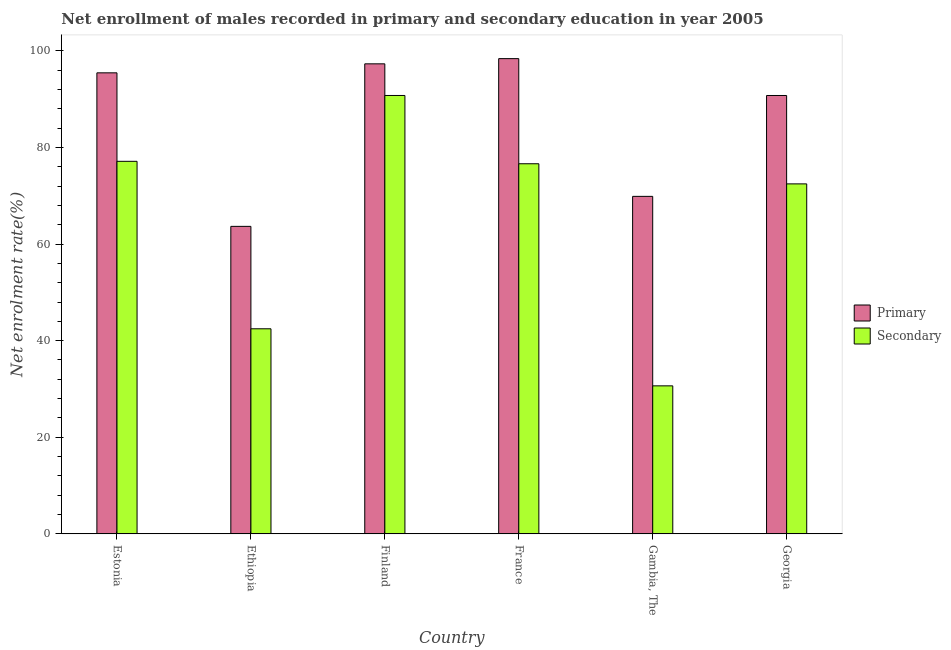How many bars are there on the 2nd tick from the right?
Offer a very short reply. 2. What is the enrollment rate in primary education in Estonia?
Your response must be concise. 95.44. Across all countries, what is the maximum enrollment rate in secondary education?
Provide a succinct answer. 90.76. Across all countries, what is the minimum enrollment rate in primary education?
Keep it short and to the point. 63.66. In which country was the enrollment rate in primary education minimum?
Offer a terse response. Ethiopia. What is the total enrollment rate in primary education in the graph?
Offer a very short reply. 515.42. What is the difference between the enrollment rate in secondary education in France and that in Gambia, The?
Provide a short and direct response. 45.98. What is the difference between the enrollment rate in secondary education in Georgia and the enrollment rate in primary education in Ethiopia?
Provide a succinct answer. 8.8. What is the average enrollment rate in secondary education per country?
Ensure brevity in your answer.  65.01. What is the difference between the enrollment rate in primary education and enrollment rate in secondary education in France?
Provide a short and direct response. 21.76. In how many countries, is the enrollment rate in secondary education greater than 16 %?
Your answer should be compact. 6. What is the ratio of the enrollment rate in primary education in Ethiopia to that in Finland?
Offer a terse response. 0.65. Is the enrollment rate in primary education in Ethiopia less than that in Finland?
Provide a succinct answer. Yes. What is the difference between the highest and the second highest enrollment rate in secondary education?
Offer a very short reply. 13.63. What is the difference between the highest and the lowest enrollment rate in primary education?
Ensure brevity in your answer.  34.73. Is the sum of the enrollment rate in primary education in Ethiopia and Georgia greater than the maximum enrollment rate in secondary education across all countries?
Provide a succinct answer. Yes. What does the 2nd bar from the left in Finland represents?
Provide a succinct answer. Secondary. What does the 2nd bar from the right in Ethiopia represents?
Provide a short and direct response. Primary. What is the difference between two consecutive major ticks on the Y-axis?
Keep it short and to the point. 20. Does the graph contain any zero values?
Your answer should be very brief. No. Does the graph contain grids?
Provide a short and direct response. No. Where does the legend appear in the graph?
Give a very brief answer. Center right. How many legend labels are there?
Your answer should be compact. 2. How are the legend labels stacked?
Your response must be concise. Vertical. What is the title of the graph?
Your answer should be compact. Net enrollment of males recorded in primary and secondary education in year 2005. What is the label or title of the X-axis?
Provide a succinct answer. Country. What is the label or title of the Y-axis?
Give a very brief answer. Net enrolment rate(%). What is the Net enrolment rate(%) of Primary in Estonia?
Provide a short and direct response. 95.44. What is the Net enrolment rate(%) of Secondary in Estonia?
Keep it short and to the point. 77.13. What is the Net enrolment rate(%) in Primary in Ethiopia?
Give a very brief answer. 63.66. What is the Net enrolment rate(%) in Secondary in Ethiopia?
Provide a short and direct response. 42.46. What is the Net enrolment rate(%) of Primary in Finland?
Keep it short and to the point. 97.31. What is the Net enrolment rate(%) in Secondary in Finland?
Your answer should be compact. 90.76. What is the Net enrolment rate(%) in Primary in France?
Your answer should be compact. 98.39. What is the Net enrolment rate(%) of Secondary in France?
Provide a short and direct response. 76.62. What is the Net enrolment rate(%) of Primary in Gambia, The?
Keep it short and to the point. 69.87. What is the Net enrolment rate(%) of Secondary in Gambia, The?
Offer a very short reply. 30.64. What is the Net enrolment rate(%) of Primary in Georgia?
Ensure brevity in your answer.  90.75. What is the Net enrolment rate(%) of Secondary in Georgia?
Make the answer very short. 72.46. Across all countries, what is the maximum Net enrolment rate(%) in Primary?
Provide a short and direct response. 98.39. Across all countries, what is the maximum Net enrolment rate(%) in Secondary?
Provide a short and direct response. 90.76. Across all countries, what is the minimum Net enrolment rate(%) in Primary?
Ensure brevity in your answer.  63.66. Across all countries, what is the minimum Net enrolment rate(%) in Secondary?
Your answer should be very brief. 30.64. What is the total Net enrolment rate(%) in Primary in the graph?
Your answer should be compact. 515.42. What is the total Net enrolment rate(%) in Secondary in the graph?
Ensure brevity in your answer.  390.06. What is the difference between the Net enrolment rate(%) in Primary in Estonia and that in Ethiopia?
Your answer should be compact. 31.79. What is the difference between the Net enrolment rate(%) in Secondary in Estonia and that in Ethiopia?
Make the answer very short. 34.67. What is the difference between the Net enrolment rate(%) in Primary in Estonia and that in Finland?
Keep it short and to the point. -1.86. What is the difference between the Net enrolment rate(%) in Secondary in Estonia and that in Finland?
Offer a very short reply. -13.63. What is the difference between the Net enrolment rate(%) in Primary in Estonia and that in France?
Your response must be concise. -2.94. What is the difference between the Net enrolment rate(%) in Secondary in Estonia and that in France?
Your answer should be very brief. 0.5. What is the difference between the Net enrolment rate(%) of Primary in Estonia and that in Gambia, The?
Ensure brevity in your answer.  25.57. What is the difference between the Net enrolment rate(%) of Secondary in Estonia and that in Gambia, The?
Your response must be concise. 46.48. What is the difference between the Net enrolment rate(%) in Primary in Estonia and that in Georgia?
Keep it short and to the point. 4.69. What is the difference between the Net enrolment rate(%) of Secondary in Estonia and that in Georgia?
Your response must be concise. 4.67. What is the difference between the Net enrolment rate(%) in Primary in Ethiopia and that in Finland?
Your answer should be compact. -33.65. What is the difference between the Net enrolment rate(%) of Secondary in Ethiopia and that in Finland?
Offer a terse response. -48.3. What is the difference between the Net enrolment rate(%) in Primary in Ethiopia and that in France?
Your answer should be very brief. -34.73. What is the difference between the Net enrolment rate(%) of Secondary in Ethiopia and that in France?
Your answer should be compact. -34.16. What is the difference between the Net enrolment rate(%) in Primary in Ethiopia and that in Gambia, The?
Your response must be concise. -6.21. What is the difference between the Net enrolment rate(%) of Secondary in Ethiopia and that in Gambia, The?
Make the answer very short. 11.81. What is the difference between the Net enrolment rate(%) in Primary in Ethiopia and that in Georgia?
Keep it short and to the point. -27.1. What is the difference between the Net enrolment rate(%) in Secondary in Ethiopia and that in Georgia?
Offer a terse response. -30. What is the difference between the Net enrolment rate(%) in Primary in Finland and that in France?
Give a very brief answer. -1.08. What is the difference between the Net enrolment rate(%) in Secondary in Finland and that in France?
Offer a very short reply. 14.14. What is the difference between the Net enrolment rate(%) of Primary in Finland and that in Gambia, The?
Your response must be concise. 27.44. What is the difference between the Net enrolment rate(%) of Secondary in Finland and that in Gambia, The?
Your answer should be compact. 60.12. What is the difference between the Net enrolment rate(%) in Primary in Finland and that in Georgia?
Ensure brevity in your answer.  6.55. What is the difference between the Net enrolment rate(%) in Secondary in Finland and that in Georgia?
Your answer should be very brief. 18.3. What is the difference between the Net enrolment rate(%) of Primary in France and that in Gambia, The?
Provide a succinct answer. 28.51. What is the difference between the Net enrolment rate(%) of Secondary in France and that in Gambia, The?
Offer a terse response. 45.98. What is the difference between the Net enrolment rate(%) in Primary in France and that in Georgia?
Offer a very short reply. 7.63. What is the difference between the Net enrolment rate(%) in Secondary in France and that in Georgia?
Provide a short and direct response. 4.17. What is the difference between the Net enrolment rate(%) of Primary in Gambia, The and that in Georgia?
Make the answer very short. -20.88. What is the difference between the Net enrolment rate(%) of Secondary in Gambia, The and that in Georgia?
Your answer should be compact. -41.81. What is the difference between the Net enrolment rate(%) in Primary in Estonia and the Net enrolment rate(%) in Secondary in Ethiopia?
Ensure brevity in your answer.  52.99. What is the difference between the Net enrolment rate(%) of Primary in Estonia and the Net enrolment rate(%) of Secondary in Finland?
Your response must be concise. 4.69. What is the difference between the Net enrolment rate(%) of Primary in Estonia and the Net enrolment rate(%) of Secondary in France?
Make the answer very short. 18.82. What is the difference between the Net enrolment rate(%) in Primary in Estonia and the Net enrolment rate(%) in Secondary in Gambia, The?
Provide a short and direct response. 64.8. What is the difference between the Net enrolment rate(%) of Primary in Estonia and the Net enrolment rate(%) of Secondary in Georgia?
Your response must be concise. 22.99. What is the difference between the Net enrolment rate(%) of Primary in Ethiopia and the Net enrolment rate(%) of Secondary in Finland?
Provide a short and direct response. -27.1. What is the difference between the Net enrolment rate(%) in Primary in Ethiopia and the Net enrolment rate(%) in Secondary in France?
Give a very brief answer. -12.96. What is the difference between the Net enrolment rate(%) in Primary in Ethiopia and the Net enrolment rate(%) in Secondary in Gambia, The?
Your answer should be very brief. 33.02. What is the difference between the Net enrolment rate(%) in Primary in Ethiopia and the Net enrolment rate(%) in Secondary in Georgia?
Provide a short and direct response. -8.8. What is the difference between the Net enrolment rate(%) of Primary in Finland and the Net enrolment rate(%) of Secondary in France?
Offer a very short reply. 20.69. What is the difference between the Net enrolment rate(%) of Primary in Finland and the Net enrolment rate(%) of Secondary in Gambia, The?
Offer a terse response. 66.67. What is the difference between the Net enrolment rate(%) of Primary in Finland and the Net enrolment rate(%) of Secondary in Georgia?
Your answer should be compact. 24.85. What is the difference between the Net enrolment rate(%) of Primary in France and the Net enrolment rate(%) of Secondary in Gambia, The?
Your response must be concise. 67.74. What is the difference between the Net enrolment rate(%) in Primary in France and the Net enrolment rate(%) in Secondary in Georgia?
Provide a short and direct response. 25.93. What is the difference between the Net enrolment rate(%) in Primary in Gambia, The and the Net enrolment rate(%) in Secondary in Georgia?
Ensure brevity in your answer.  -2.59. What is the average Net enrolment rate(%) of Primary per country?
Ensure brevity in your answer.  85.9. What is the average Net enrolment rate(%) in Secondary per country?
Offer a very short reply. 65.01. What is the difference between the Net enrolment rate(%) of Primary and Net enrolment rate(%) of Secondary in Estonia?
Your response must be concise. 18.32. What is the difference between the Net enrolment rate(%) of Primary and Net enrolment rate(%) of Secondary in Ethiopia?
Keep it short and to the point. 21.2. What is the difference between the Net enrolment rate(%) of Primary and Net enrolment rate(%) of Secondary in Finland?
Offer a terse response. 6.55. What is the difference between the Net enrolment rate(%) of Primary and Net enrolment rate(%) of Secondary in France?
Offer a terse response. 21.76. What is the difference between the Net enrolment rate(%) of Primary and Net enrolment rate(%) of Secondary in Gambia, The?
Make the answer very short. 39.23. What is the difference between the Net enrolment rate(%) in Primary and Net enrolment rate(%) in Secondary in Georgia?
Keep it short and to the point. 18.3. What is the ratio of the Net enrolment rate(%) in Primary in Estonia to that in Ethiopia?
Offer a very short reply. 1.5. What is the ratio of the Net enrolment rate(%) in Secondary in Estonia to that in Ethiopia?
Provide a succinct answer. 1.82. What is the ratio of the Net enrolment rate(%) in Primary in Estonia to that in Finland?
Offer a terse response. 0.98. What is the ratio of the Net enrolment rate(%) of Secondary in Estonia to that in Finland?
Make the answer very short. 0.85. What is the ratio of the Net enrolment rate(%) in Primary in Estonia to that in France?
Offer a terse response. 0.97. What is the ratio of the Net enrolment rate(%) in Secondary in Estonia to that in France?
Provide a succinct answer. 1.01. What is the ratio of the Net enrolment rate(%) of Primary in Estonia to that in Gambia, The?
Keep it short and to the point. 1.37. What is the ratio of the Net enrolment rate(%) in Secondary in Estonia to that in Gambia, The?
Offer a terse response. 2.52. What is the ratio of the Net enrolment rate(%) of Primary in Estonia to that in Georgia?
Make the answer very short. 1.05. What is the ratio of the Net enrolment rate(%) in Secondary in Estonia to that in Georgia?
Your response must be concise. 1.06. What is the ratio of the Net enrolment rate(%) in Primary in Ethiopia to that in Finland?
Give a very brief answer. 0.65. What is the ratio of the Net enrolment rate(%) in Secondary in Ethiopia to that in Finland?
Make the answer very short. 0.47. What is the ratio of the Net enrolment rate(%) in Primary in Ethiopia to that in France?
Offer a very short reply. 0.65. What is the ratio of the Net enrolment rate(%) in Secondary in Ethiopia to that in France?
Your answer should be compact. 0.55. What is the ratio of the Net enrolment rate(%) of Primary in Ethiopia to that in Gambia, The?
Your response must be concise. 0.91. What is the ratio of the Net enrolment rate(%) in Secondary in Ethiopia to that in Gambia, The?
Offer a terse response. 1.39. What is the ratio of the Net enrolment rate(%) of Primary in Ethiopia to that in Georgia?
Ensure brevity in your answer.  0.7. What is the ratio of the Net enrolment rate(%) in Secondary in Ethiopia to that in Georgia?
Provide a succinct answer. 0.59. What is the ratio of the Net enrolment rate(%) of Primary in Finland to that in France?
Your response must be concise. 0.99. What is the ratio of the Net enrolment rate(%) of Secondary in Finland to that in France?
Provide a short and direct response. 1.18. What is the ratio of the Net enrolment rate(%) in Primary in Finland to that in Gambia, The?
Give a very brief answer. 1.39. What is the ratio of the Net enrolment rate(%) of Secondary in Finland to that in Gambia, The?
Make the answer very short. 2.96. What is the ratio of the Net enrolment rate(%) of Primary in Finland to that in Georgia?
Ensure brevity in your answer.  1.07. What is the ratio of the Net enrolment rate(%) of Secondary in Finland to that in Georgia?
Your response must be concise. 1.25. What is the ratio of the Net enrolment rate(%) in Primary in France to that in Gambia, The?
Offer a terse response. 1.41. What is the ratio of the Net enrolment rate(%) in Secondary in France to that in Gambia, The?
Keep it short and to the point. 2.5. What is the ratio of the Net enrolment rate(%) of Primary in France to that in Georgia?
Ensure brevity in your answer.  1.08. What is the ratio of the Net enrolment rate(%) in Secondary in France to that in Georgia?
Your answer should be very brief. 1.06. What is the ratio of the Net enrolment rate(%) of Primary in Gambia, The to that in Georgia?
Give a very brief answer. 0.77. What is the ratio of the Net enrolment rate(%) of Secondary in Gambia, The to that in Georgia?
Offer a very short reply. 0.42. What is the difference between the highest and the second highest Net enrolment rate(%) in Primary?
Provide a short and direct response. 1.08. What is the difference between the highest and the second highest Net enrolment rate(%) in Secondary?
Provide a short and direct response. 13.63. What is the difference between the highest and the lowest Net enrolment rate(%) in Primary?
Provide a short and direct response. 34.73. What is the difference between the highest and the lowest Net enrolment rate(%) in Secondary?
Your response must be concise. 60.12. 